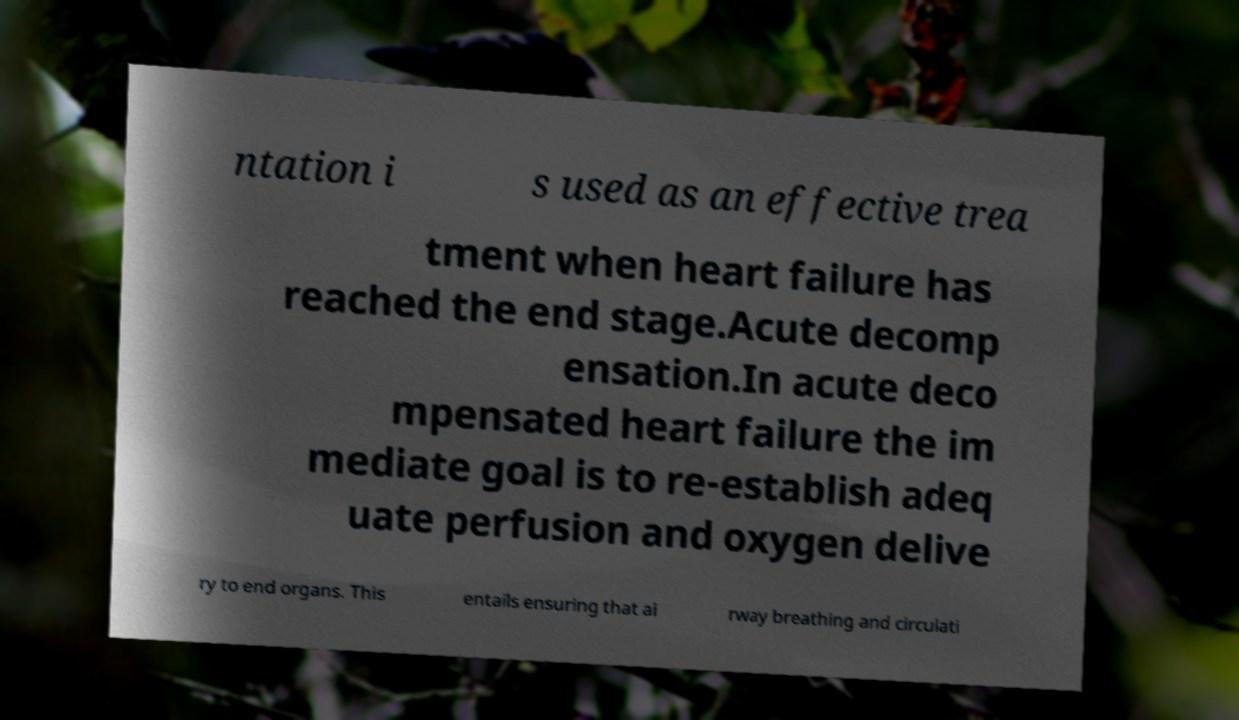Can you accurately transcribe the text from the provided image for me? ntation i s used as an effective trea tment when heart failure has reached the end stage.Acute decomp ensation.In acute deco mpensated heart failure the im mediate goal is to re-establish adeq uate perfusion and oxygen delive ry to end organs. This entails ensuring that ai rway breathing and circulati 